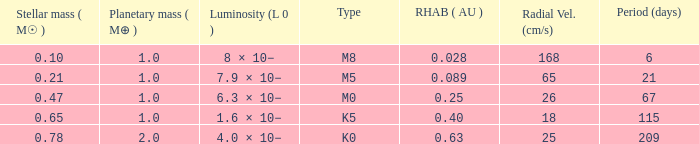What is the highest planetary mass having an RV (cm/s) of 65 and a Period (days) less than 21? None. 